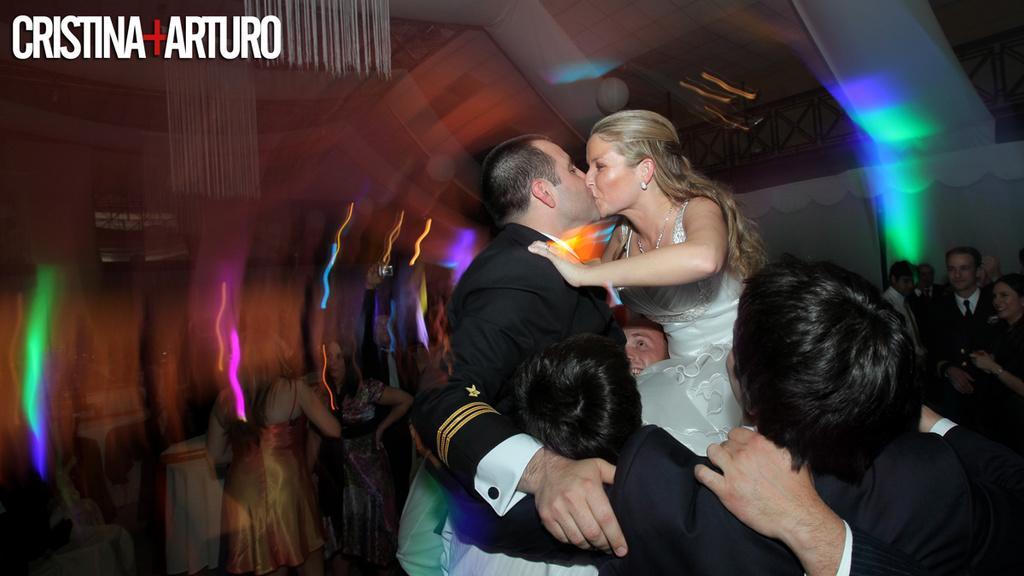Describe this image in one or two sentences. In this image I see a man and a woman who are kissing each other and I see number of people and I see the watermark over here. In the background I see the wall and I see the railing over here and I see the lights which are colorful. 